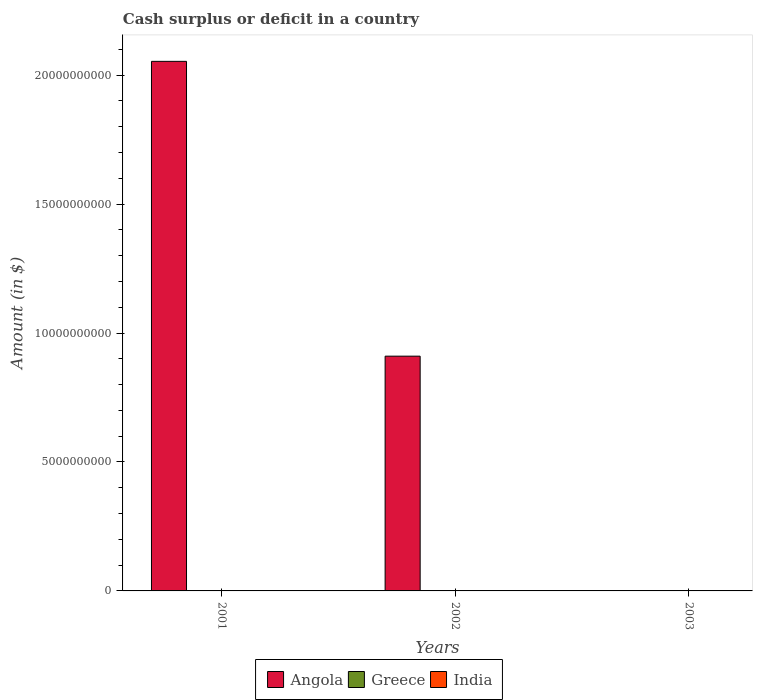Are the number of bars per tick equal to the number of legend labels?
Your answer should be compact. No. Are the number of bars on each tick of the X-axis equal?
Provide a short and direct response. No. How many bars are there on the 2nd tick from the left?
Ensure brevity in your answer.  1. How many bars are there on the 1st tick from the right?
Offer a very short reply. 0. What is the amount of cash surplus or deficit in India in 2003?
Give a very brief answer. 0. What is the total amount of cash surplus or deficit in Greece in the graph?
Provide a short and direct response. 0. What is the difference between the amount of cash surplus or deficit in Angola in 2001 and that in 2002?
Give a very brief answer. 1.14e+1. What is the difference between the amount of cash surplus or deficit in India in 2001 and the amount of cash surplus or deficit in Angola in 2002?
Make the answer very short. -9.10e+09. What is the difference between the highest and the lowest amount of cash surplus or deficit in Angola?
Provide a succinct answer. 2.05e+1. In how many years, is the amount of cash surplus or deficit in Greece greater than the average amount of cash surplus or deficit in Greece taken over all years?
Offer a very short reply. 0. Is it the case that in every year, the sum of the amount of cash surplus or deficit in Greece and amount of cash surplus or deficit in Angola is greater than the amount of cash surplus or deficit in India?
Your response must be concise. No. How many bars are there?
Your answer should be very brief. 2. How many years are there in the graph?
Your answer should be very brief. 3. Where does the legend appear in the graph?
Your answer should be very brief. Bottom center. What is the title of the graph?
Your response must be concise. Cash surplus or deficit in a country. What is the label or title of the Y-axis?
Give a very brief answer. Amount (in $). What is the Amount (in $) in Angola in 2001?
Ensure brevity in your answer.  2.05e+1. What is the Amount (in $) in Greece in 2001?
Keep it short and to the point. 0. What is the Amount (in $) of Angola in 2002?
Ensure brevity in your answer.  9.10e+09. What is the Amount (in $) of Angola in 2003?
Ensure brevity in your answer.  0. Across all years, what is the maximum Amount (in $) in Angola?
Your answer should be very brief. 2.05e+1. What is the total Amount (in $) in Angola in the graph?
Your answer should be compact. 2.96e+1. What is the total Amount (in $) in India in the graph?
Your answer should be compact. 0. What is the difference between the Amount (in $) of Angola in 2001 and that in 2002?
Provide a succinct answer. 1.14e+1. What is the average Amount (in $) of Angola per year?
Your answer should be compact. 9.88e+09. What is the ratio of the Amount (in $) of Angola in 2001 to that in 2002?
Ensure brevity in your answer.  2.26. What is the difference between the highest and the lowest Amount (in $) in Angola?
Keep it short and to the point. 2.05e+1. 